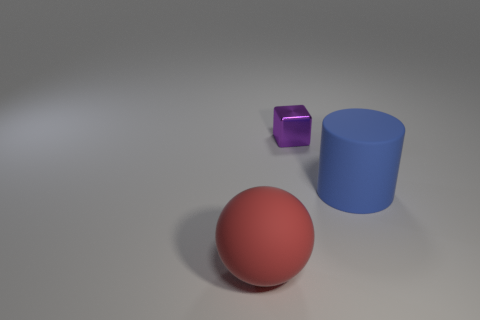Add 1 tiny red cylinders. How many objects exist? 4 Subtract all spheres. How many objects are left? 2 Subtract all cyan metallic cylinders. Subtract all tiny things. How many objects are left? 2 Add 2 big blue matte things. How many big blue matte things are left? 3 Add 2 big blue rubber cylinders. How many big blue rubber cylinders exist? 3 Subtract 0 gray cylinders. How many objects are left? 3 Subtract all yellow balls. Subtract all red cylinders. How many balls are left? 1 